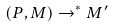<formula> <loc_0><loc_0><loc_500><loc_500>( P , M ) \rightarrow ^ { * } M ^ { \prime }</formula> 